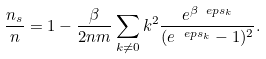Convert formula to latex. <formula><loc_0><loc_0><loc_500><loc_500>\frac { n _ { s } } { n } = 1 - \frac { \beta } { 2 n m } \sum _ { k \neq 0 } k ^ { 2 } \frac { e ^ { \beta \ e p s _ { k } } } { ( e ^ { \ e p s _ { k } } - 1 ) ^ { 2 } } .</formula> 